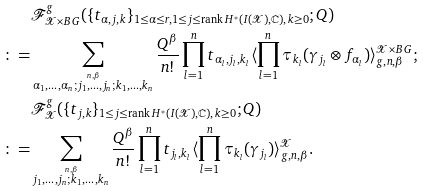<formula> <loc_0><loc_0><loc_500><loc_500>& \mathcal { F } _ { \mathcal { X } \times B G } ^ { g } ( \{ t _ { \alpha , j , k } \} _ { 1 \leq \alpha \leq r , 1 \leq j \leq \text {rank} \, H ^ { * } ( I ( \mathcal { X } ) , \mathbb { C } ) , k \geq 0 } ; Q ) \\ \colon = & \sum _ { \overset { n , \beta } { \alpha _ { 1 } , \dots , \alpha _ { n } ; j _ { 1 } , \dots , j _ { n } ; k _ { 1 } , \dots , k _ { n } } } \frac { Q ^ { \beta } } { n ! } \prod _ { l = 1 } ^ { n } t _ { \alpha _ { l } , j _ { l } , k _ { l } } \langle \prod _ { l = 1 } ^ { n } \tau _ { k _ { l } } ( \gamma _ { j _ { l } } \otimes f _ { \alpha _ { l } } ) \rangle _ { g , n , \beta } ^ { \mathcal { X } \times B G } ; \\ & \mathcal { F } _ { \mathcal { X } } ^ { g } ( \{ t _ { j , k } \} _ { 1 \leq j \leq \text {rank} \, H ^ { * } ( I ( \mathcal { X } ) , \mathbb { C } ) , k \geq 0 } ; Q ) \\ \colon = & \sum _ { \overset { n , \beta } { j _ { 1 } , \dots , j _ { n } ; k _ { 1 } , \dots , k _ { n } } } \frac { Q ^ { \beta } } { n ! } \prod _ { l = 1 } ^ { n } t _ { j _ { l } , k _ { l } } \langle \prod _ { l = 1 } ^ { n } \tau _ { k _ { l } } ( \gamma _ { j _ { l } } ) \rangle _ { g , n , \beta } ^ { \mathcal { X } } . \\</formula> 